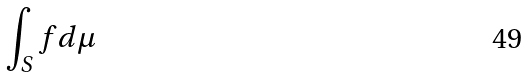<formula> <loc_0><loc_0><loc_500><loc_500>\int _ { S } f d \mu</formula> 